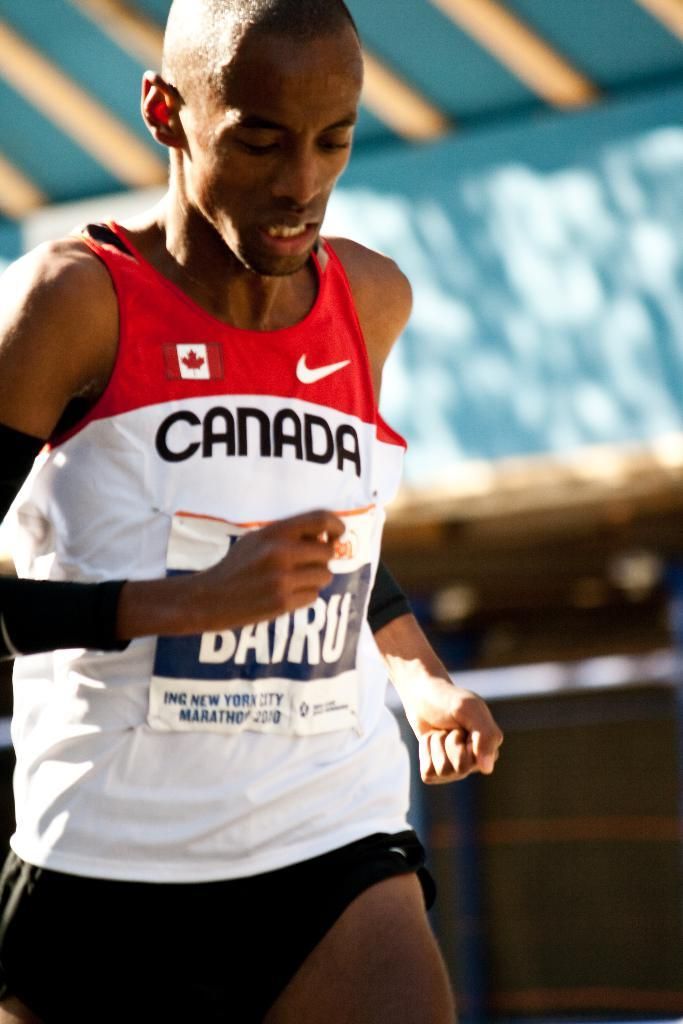<image>
Give a short and clear explanation of the subsequent image. A black man running wearing a canada shirt while doing so 